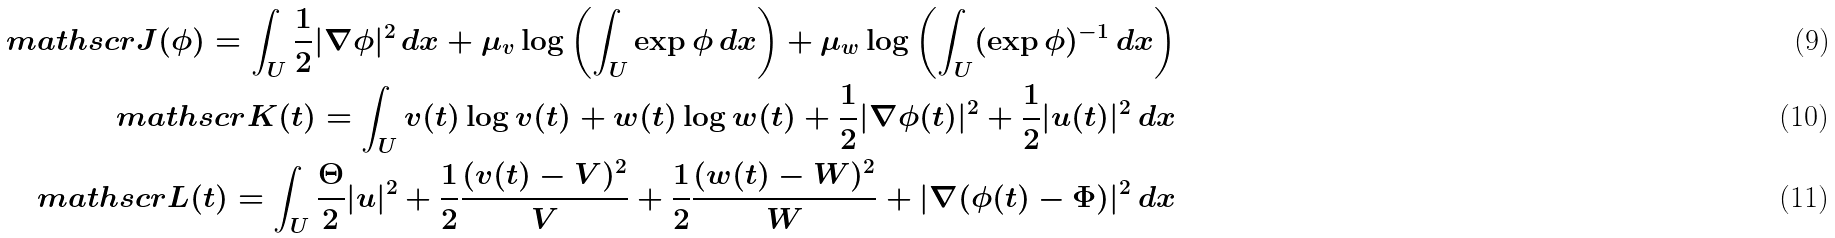<formula> <loc_0><loc_0><loc_500><loc_500>\ m a t h s c r { J } ( \phi ) = \int _ { U } \frac { 1 } { 2 } | \nabla \phi | ^ { 2 } \, d x + \mu _ { v } \log \left ( \int _ { U } \exp \phi \, d x \right ) + \mu _ { w } \log \left ( \int _ { U } ( \exp \phi ) ^ { - 1 } \, d x \right ) \\ \ m a t h s c r { K } ( t ) = \int _ { U } v ( t ) \log v ( t ) + w ( t ) \log w ( t ) + \frac { 1 } { 2 } | \nabla \phi ( t ) | ^ { 2 } + \frac { 1 } { 2 } | u ( t ) | ^ { 2 } \, d x \\ \ m a t h s c r { L } ( t ) = \int _ { U } \frac { \Theta } { 2 } | u | ^ { 2 } + \frac { 1 } { 2 } \frac { ( v ( t ) - V ) ^ { 2 } } { V } + \frac { 1 } { 2 } \frac { ( w ( t ) - W ) ^ { 2 } } { W } + | \nabla ( \phi ( t ) - \Phi ) | ^ { 2 } \, d x</formula> 